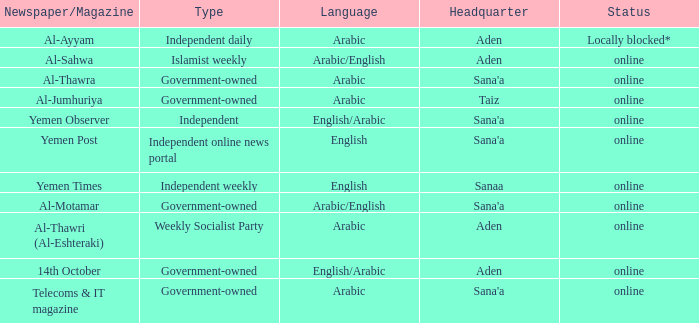What is the main office for an independent online news portal? Sana'a. Would you be able to parse every entry in this table? {'header': ['Newspaper/Magazine', 'Type', 'Language', 'Headquarter', 'Status'], 'rows': [['Al-Ayyam', 'Independent daily', 'Arabic', 'Aden', 'Locally blocked*'], ['Al-Sahwa', 'Islamist weekly', 'Arabic/English', 'Aden', 'online'], ['Al-Thawra', 'Government-owned', 'Arabic', "Sana'a", 'online'], ['Al-Jumhuriya', 'Government-owned', 'Arabic', 'Taiz', 'online'], ['Yemen Observer', 'Independent', 'English/Arabic', "Sana'a", 'online'], ['Yemen Post', 'Independent online news portal', 'English', "Sana'a", 'online'], ['Yemen Times', 'Independent weekly', 'English', 'Sanaa', 'online'], ['Al-Motamar', 'Government-owned', 'Arabic/English', "Sana'a", 'online'], ['Al-Thawri (Al-Eshteraki)', 'Weekly Socialist Party', 'Arabic', 'Aden', 'online'], ['14th October', 'Government-owned', 'English/Arabic', 'Aden', 'online'], ['Telecoms & IT magazine', 'Government-owned', 'Arabic', "Sana'a", 'online']]} 